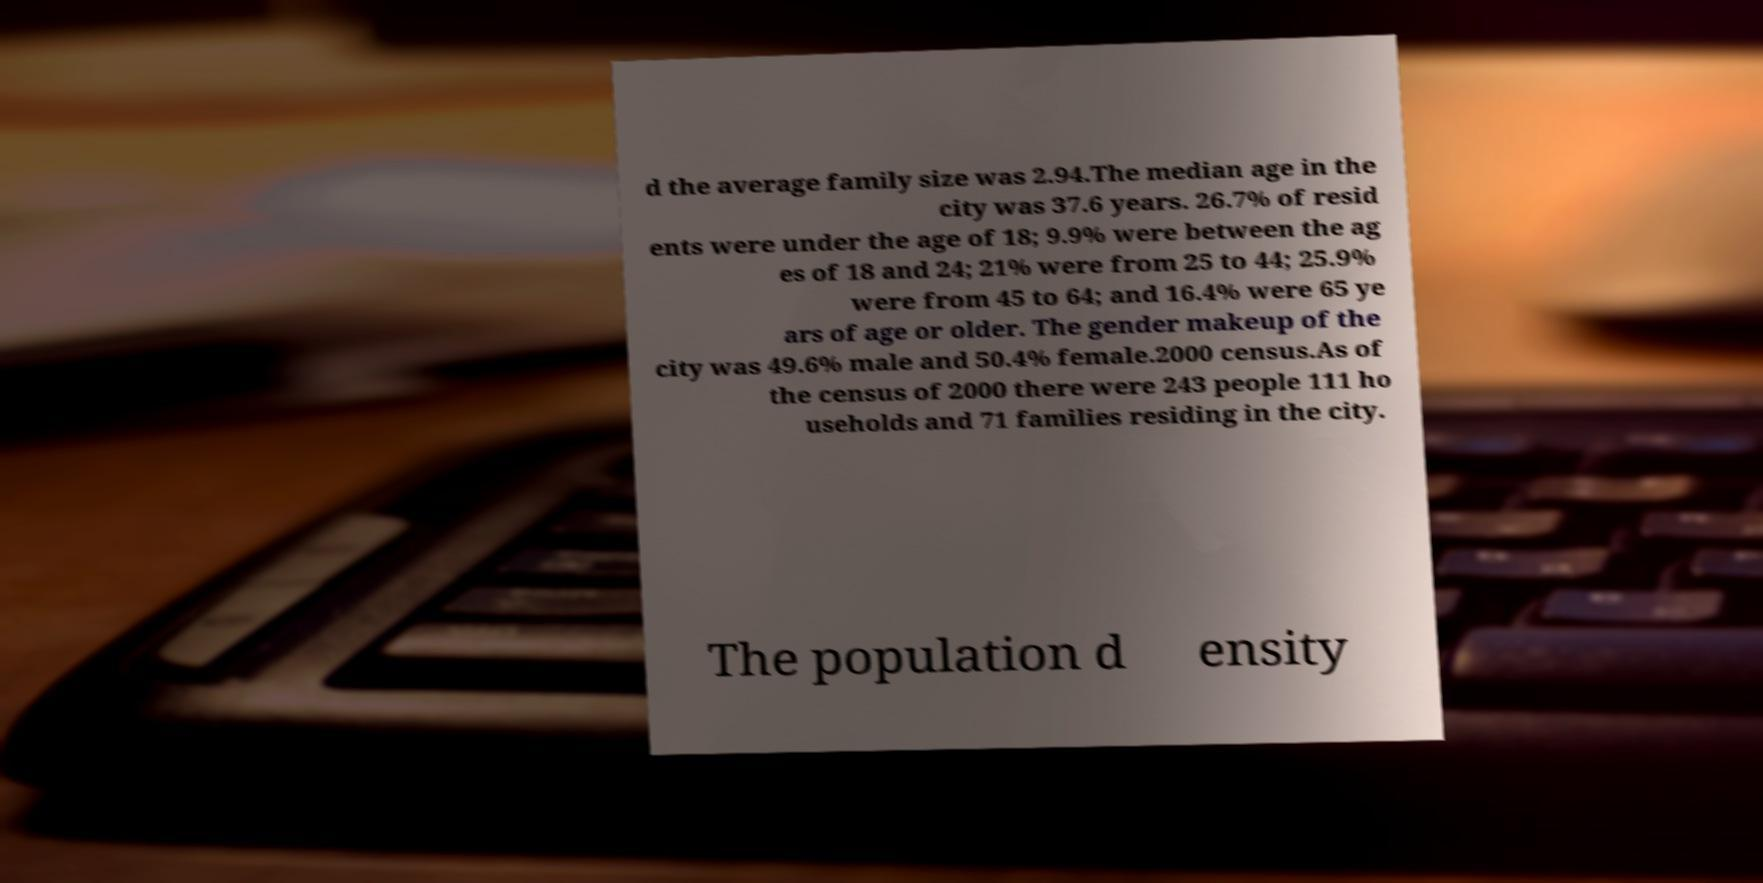Can you accurately transcribe the text from the provided image for me? d the average family size was 2.94.The median age in the city was 37.6 years. 26.7% of resid ents were under the age of 18; 9.9% were between the ag es of 18 and 24; 21% were from 25 to 44; 25.9% were from 45 to 64; and 16.4% were 65 ye ars of age or older. The gender makeup of the city was 49.6% male and 50.4% female.2000 census.As of the census of 2000 there were 243 people 111 ho useholds and 71 families residing in the city. The population d ensity 